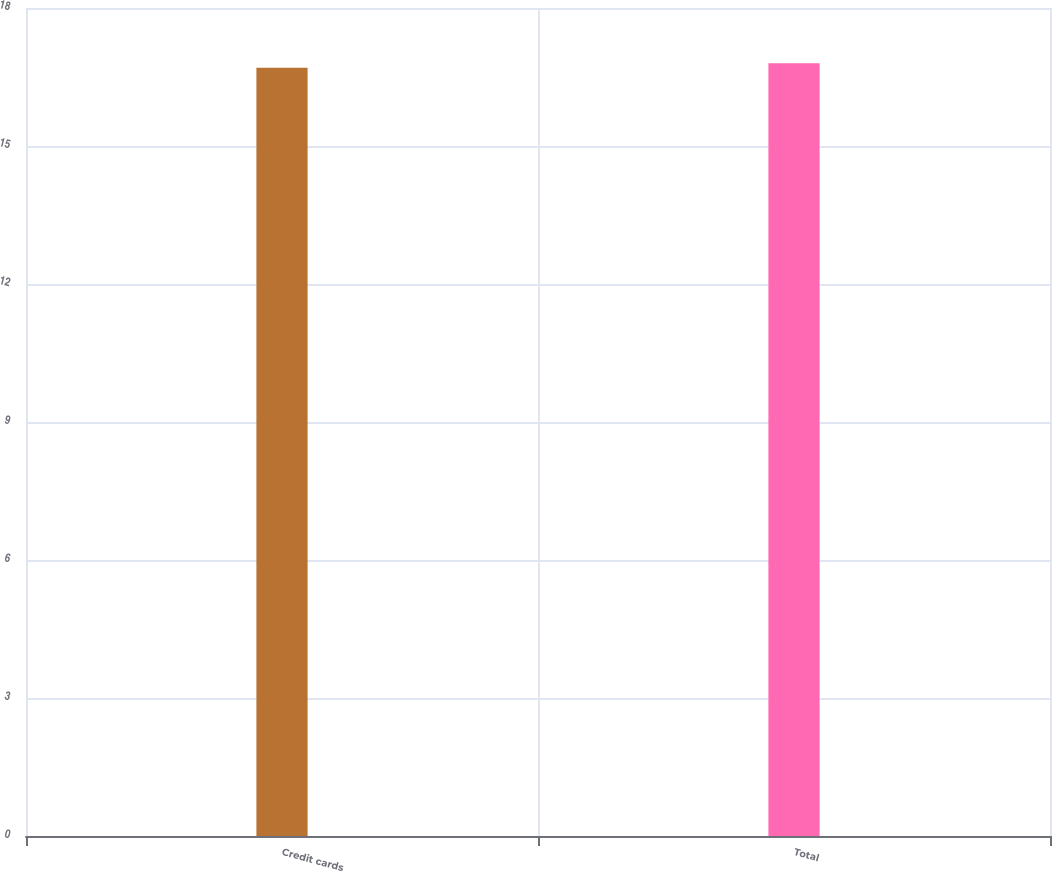Convert chart. <chart><loc_0><loc_0><loc_500><loc_500><bar_chart><fcel>Credit cards<fcel>Total<nl><fcel>16.7<fcel>16.8<nl></chart> 